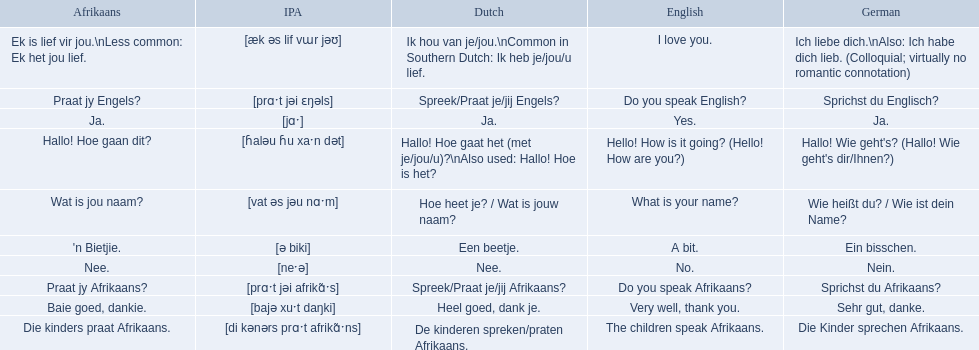What are all of the afrikaans phrases in the list? Hallo! Hoe gaan dit?, Baie goed, dankie., Praat jy Afrikaans?, Praat jy Engels?, Ja., Nee., 'n Bietjie., Wat is jou naam?, Die kinders praat Afrikaans., Ek is lief vir jou.\nLess common: Ek het jou lief. What is the english translation of each phrase? Hello! How is it going? (Hello! How are you?), Very well, thank you., Do you speak Afrikaans?, Do you speak English?, Yes., No., A bit., What is your name?, The children speak Afrikaans., I love you. And which afrikaans phrase translated to do you speak afrikaans? Praat jy Afrikaans?. 